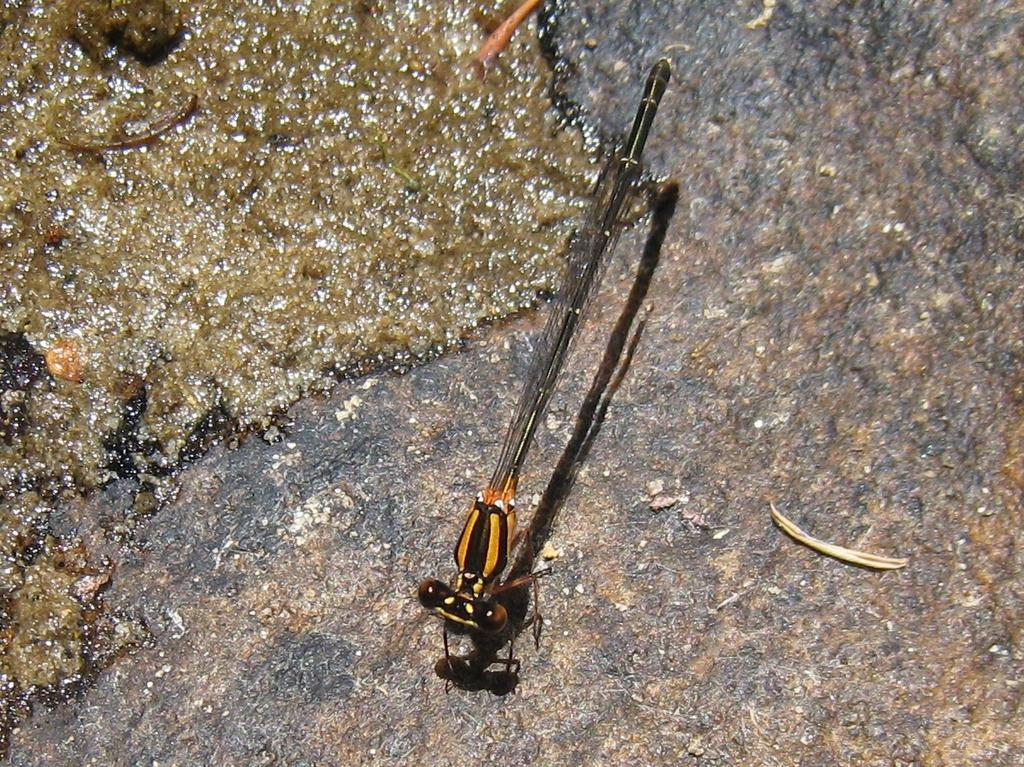What type of insect is in the image? There is a dragonfly in the image. Where is the dragonfly located? The dragonfly is on a surface. What type of pets are being discussed by the committee in the image? There is no committee or pets present in the image; it features a dragonfly on a surface. 